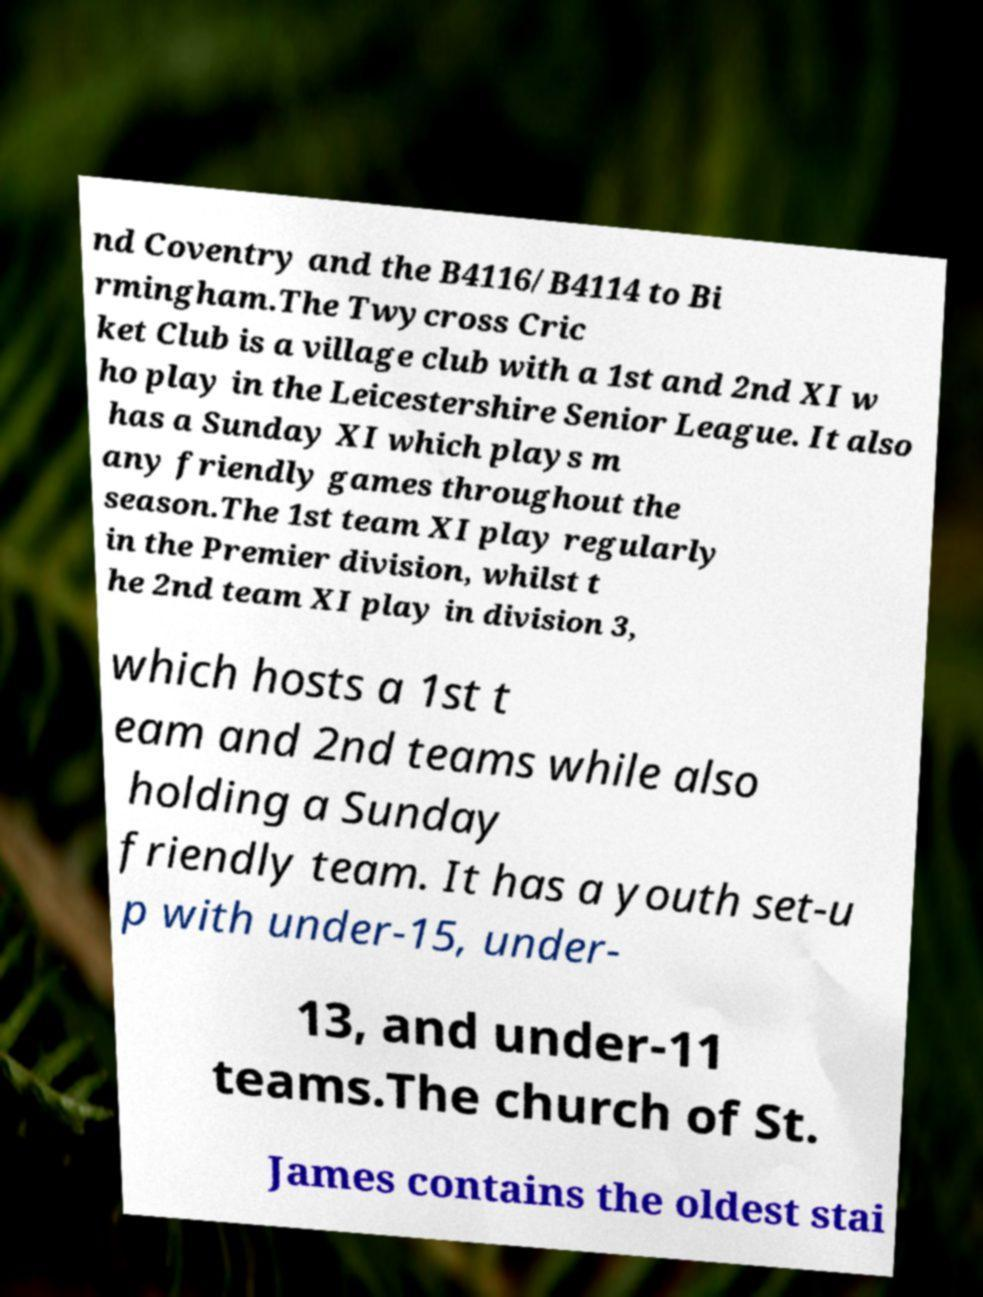For documentation purposes, I need the text within this image transcribed. Could you provide that? nd Coventry and the B4116/B4114 to Bi rmingham.The Twycross Cric ket Club is a village club with a 1st and 2nd XI w ho play in the Leicestershire Senior League. It also has a Sunday XI which plays m any friendly games throughout the season.The 1st team XI play regularly in the Premier division, whilst t he 2nd team XI play in division 3, which hosts a 1st t eam and 2nd teams while also holding a Sunday friendly team. It has a youth set-u p with under-15, under- 13, and under-11 teams.The church of St. James contains the oldest stai 